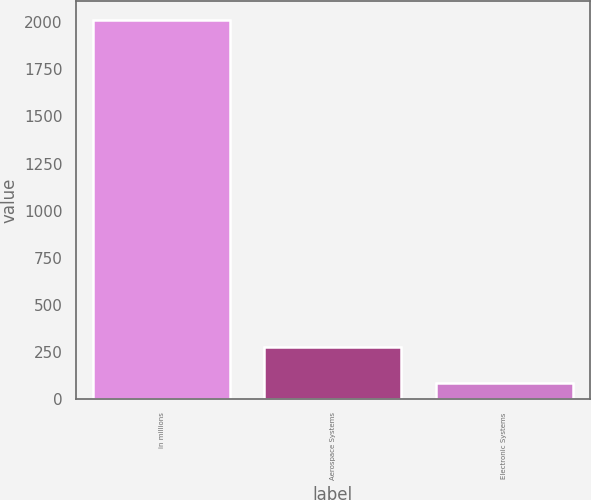Convert chart to OTSL. <chart><loc_0><loc_0><loc_500><loc_500><bar_chart><fcel>in millions<fcel>Aerospace Systems<fcel>Electronic Systems<nl><fcel>2012<fcel>276.8<fcel>84<nl></chart> 